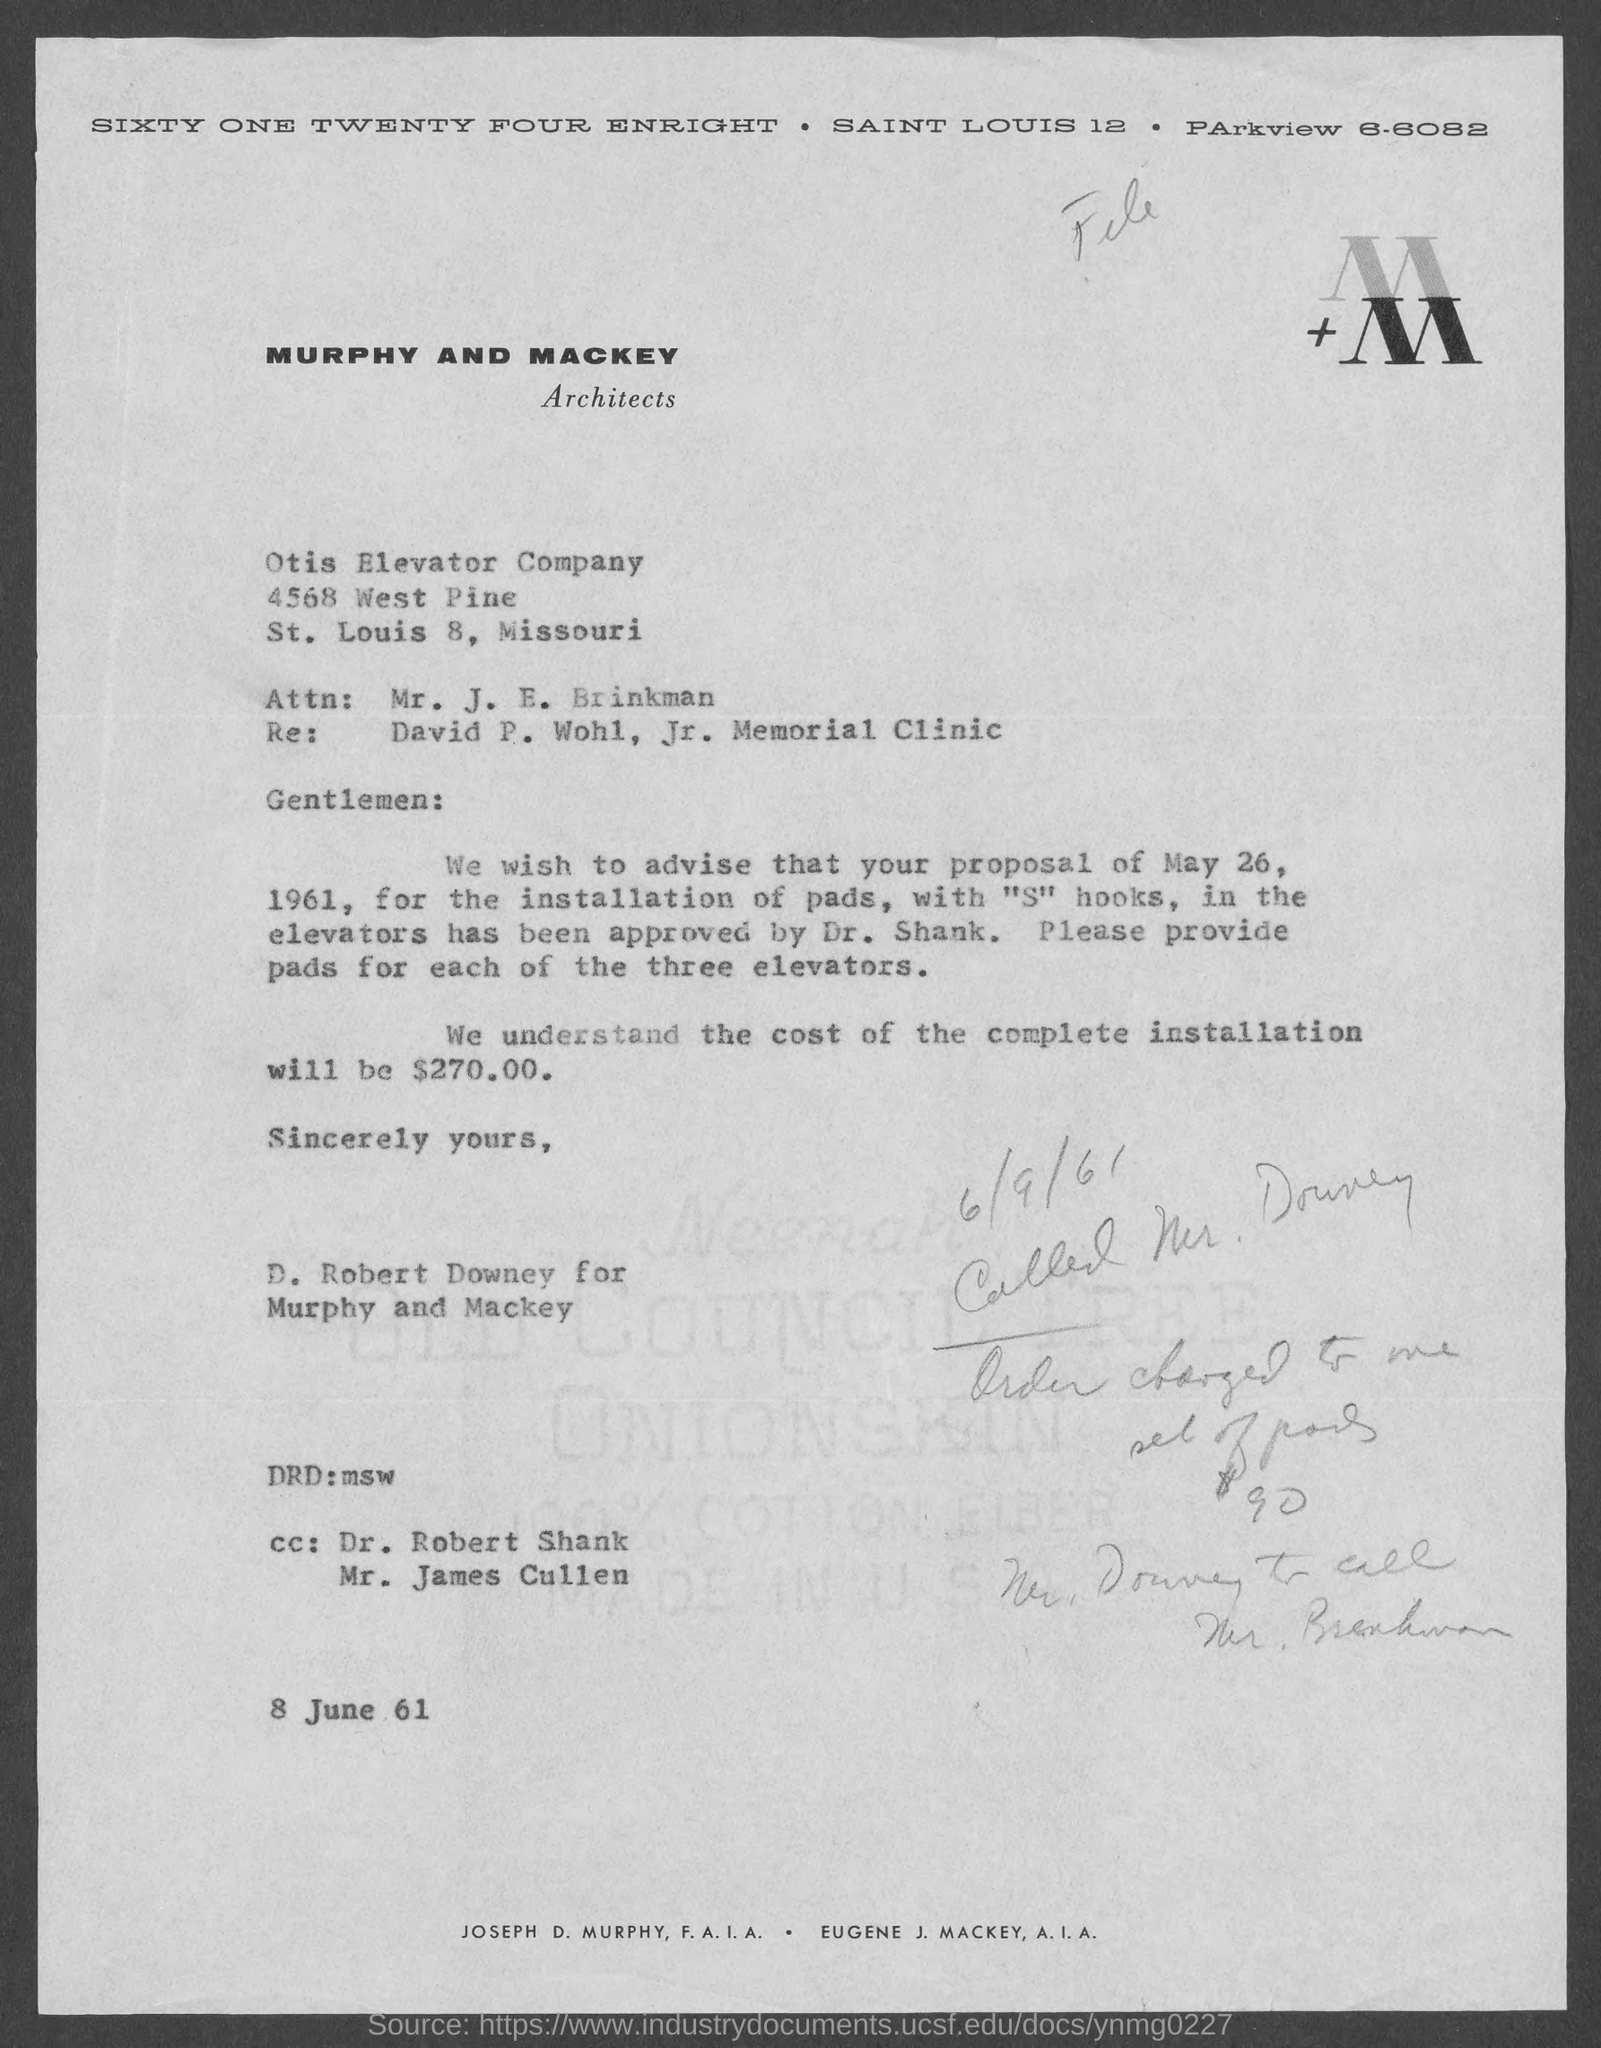Specify some key components in this picture. The proposal for the installation of pads with "S" hooks was approved by Dr. Shank. The total cost for the complete installation of pads is $270. The architects mentioned in the letterhead are Murphy and Mackey. 